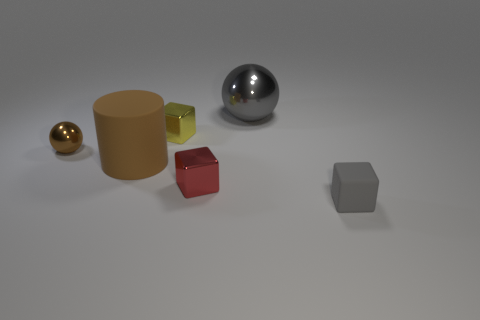What material is the ball that is the same color as the matte cylinder? metal 